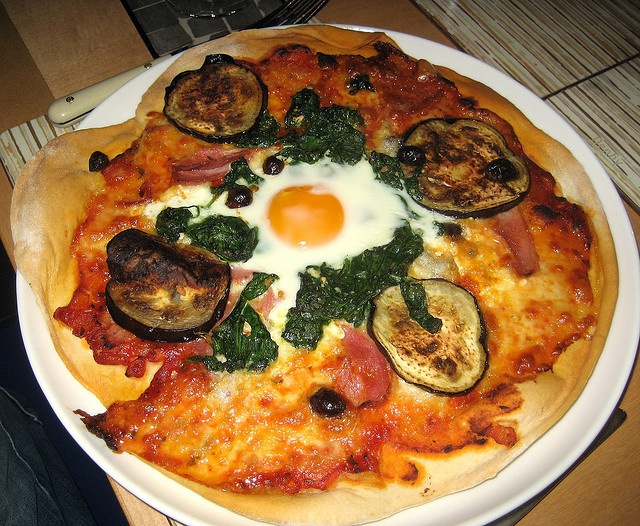Describe the objects in this image and their specific colors. I can see dining table in black, brown, beige, and maroon tones, pizza in black, brown, orange, and maroon tones, and fork in black, tan, and gray tones in this image. 